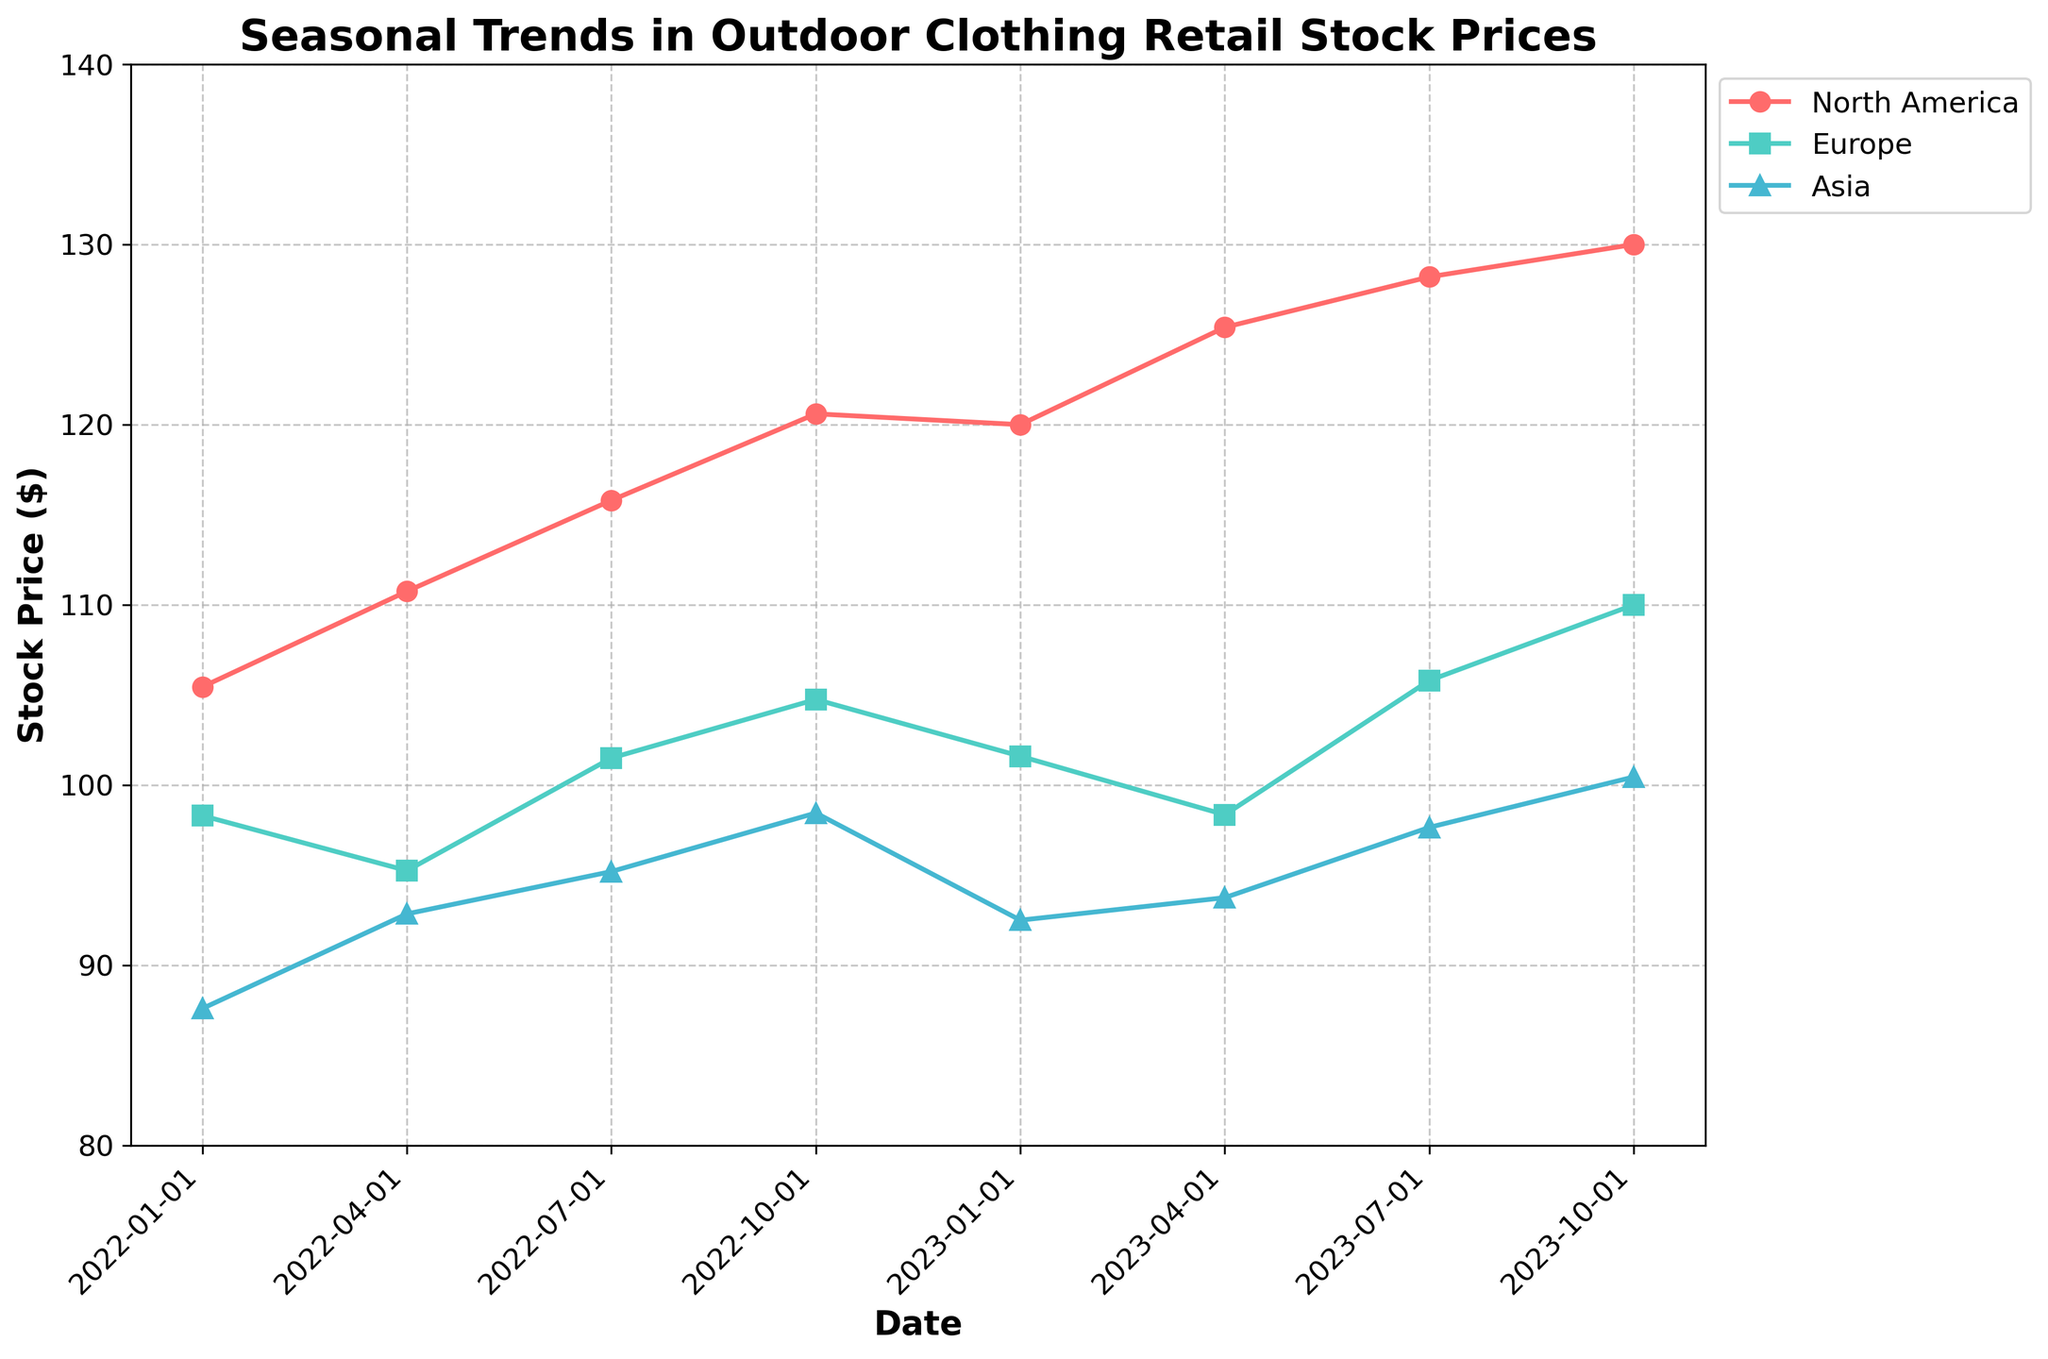What is the title of the plot? The title of the plot is often found at the top of the figure and provides a concise description of what the plot represents. In this case, the title is "Seasonal Trends in Outdoor Clothing Retail Stock Prices".
Answer: Seasonal Trends in Outdoor Clothing Retail Stock Prices How many regions are represented in the plot, and what are they? To determine the number of regions and their names, note the different colors/lines in the plot's legend. Here, three regions are represented: North America, Europe, and Asia.
Answer: Three regions: North America, Europe, and Asia Which company’s stock price is consistently the highest across all the dates? By observing the vertical positioning of the lines (stock prices) corresponding to different companies, you can identify the highest line across all dates. The line for Patagonia, representing North America in red, is consistently the highest.
Answer: Patagonia What is the stock price for Columbia on October 1, 2023? Find the point corresponding to October 1, 2023, on the horizontal axis and trace it upward to the Columbia line (Asia, shown in cyan). The stock price at this point is 100.45.
Answer: 100.45 Which company showed the largest increase in stock price from January 1, 2022, to October 1, 2023? To determine this, calculate the difference in stock price between January 1, 2022, and October 1, 2023, for each company and compare them. Patagonia (North America) had the largest increase, from 105.45 to 130.00.
Answer: Patagonia How does the stock price trend for The North Face differ between Europe and North America? Observe the trends over the dates for Europe (turquoise line) and compare it with North America's trend (red line). The North Face in Europe has a relatively steadier trend compared to the more consistent rise in North America's Patagonia stock.
Answer: The trends show that The North Face (Europe) has steadier fluctuations compared to Patagonia's consistent rise What is the overall trend in stock prices for outdoor clothing retailers from January 1, 2022, to October 1, 2023? Visually analyze the slope of the lines from the starting to ending dates. All regions show an upward trend indicating an increase in stock prices over the period.
Answer: Upward trend Are there any significant seasonal patterns in the stock prices of any company? Look for repeating patterns at specific times of the year (e.g., increases in summer). For example, Patagonia (North America) exhibits noticeable increases during the summer and autumn seasons.
Answer: Patagonia shows seasonal increases in summer and autumn Compare the stock price variation between North America and Asia from January 1, 2022, to October 1, 2023. Focus on the degree of fluctuation and overall change in stock prices. North America's Patagonia shows a steeper and more consistent rise with less fluctuation compared to Asia's Columbia, which shows more moderate changes with some fluctuation.
Answer: North America shows a steeper and more consistent rise During which quarter did The North Face in Europe reach its highest stock price? Identify the peak point on the turquoise line representing Europe for The North Face and note the corresponding quarter. The highest stock price was reached in Q4 (October 1, 2023).
Answer: Q4 (October 1, 2023) 